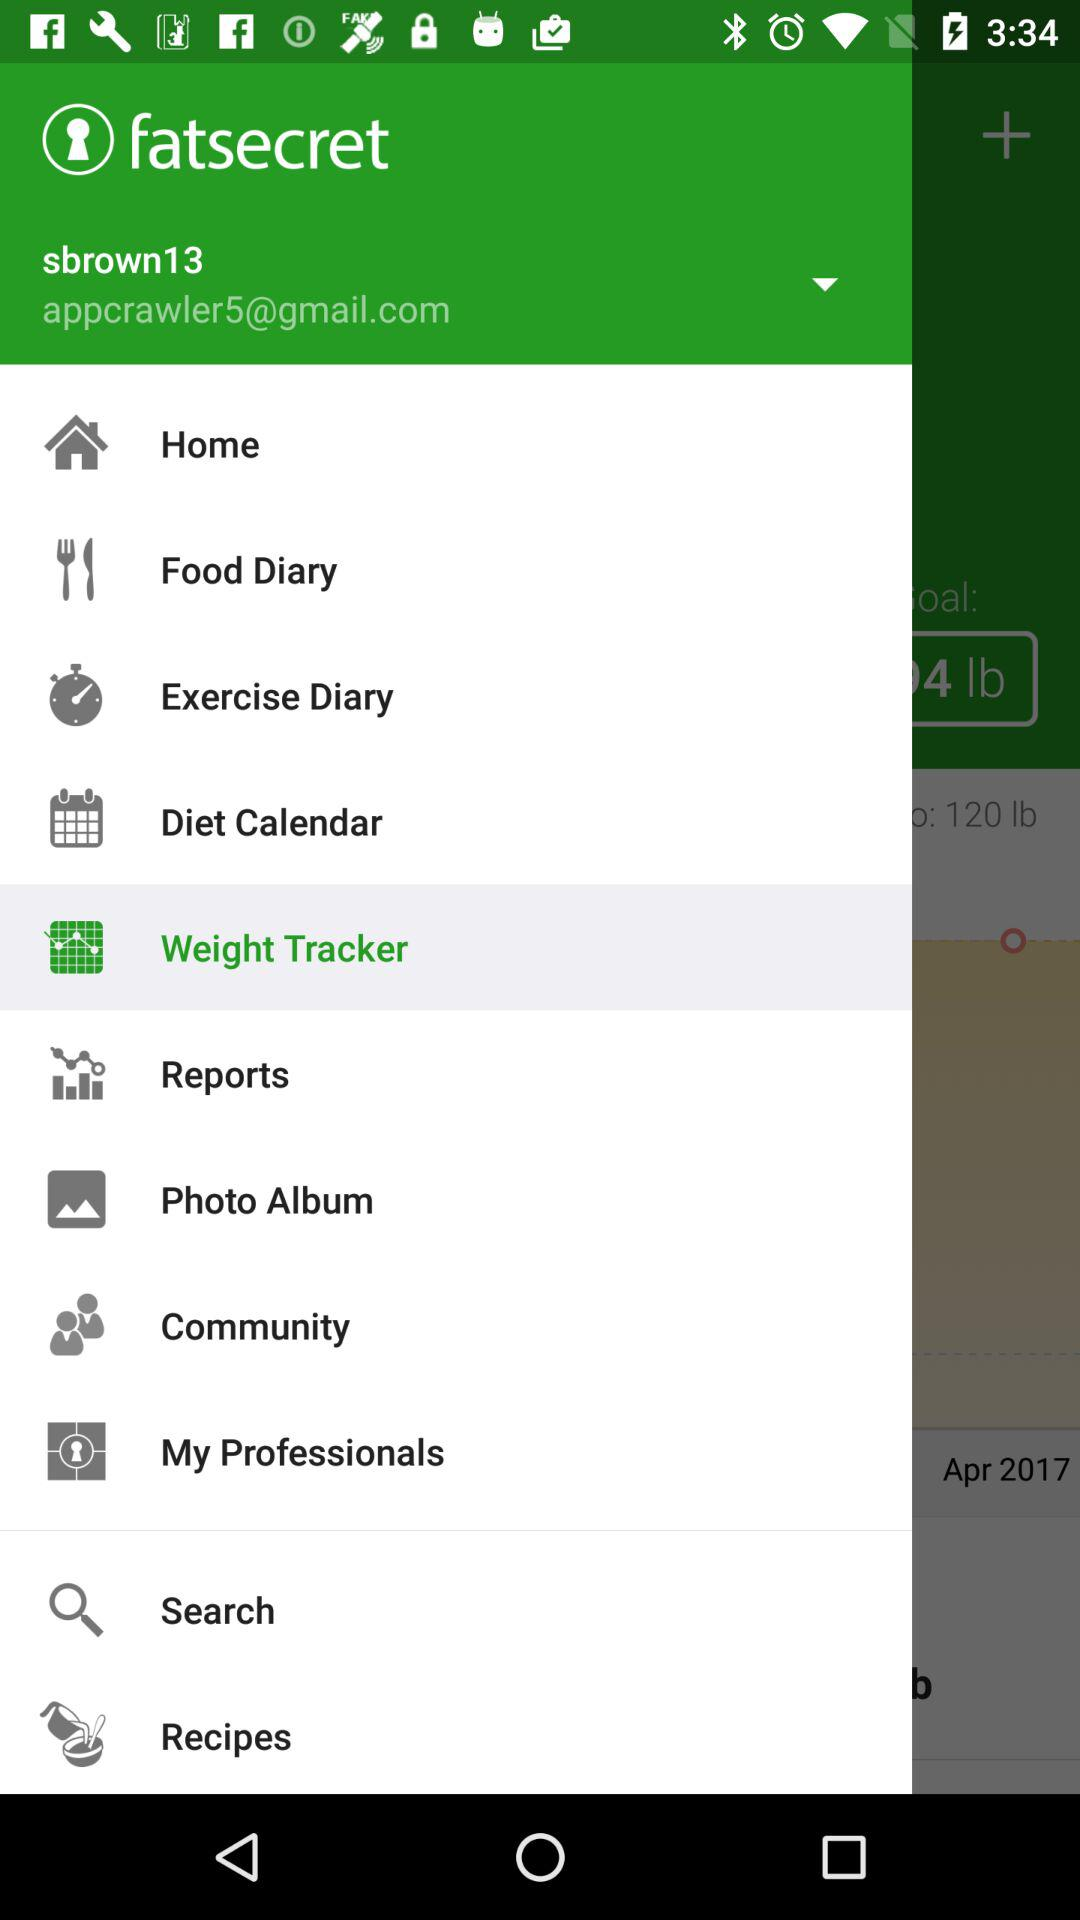What's the username? The username is "sbrown13". 